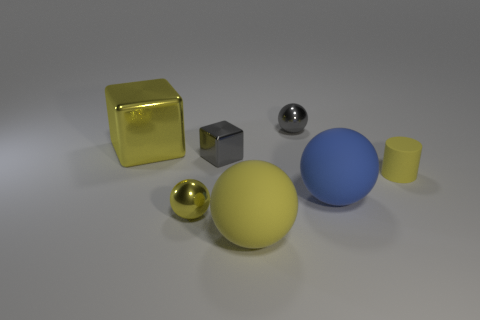Add 3 tiny balls. How many objects exist? 10 Subtract all spheres. How many objects are left? 3 Add 5 balls. How many balls are left? 9 Add 3 tiny red things. How many tiny red things exist? 3 Subtract 0 purple blocks. How many objects are left? 7 Subtract all small gray balls. Subtract all tiny yellow rubber cylinders. How many objects are left? 5 